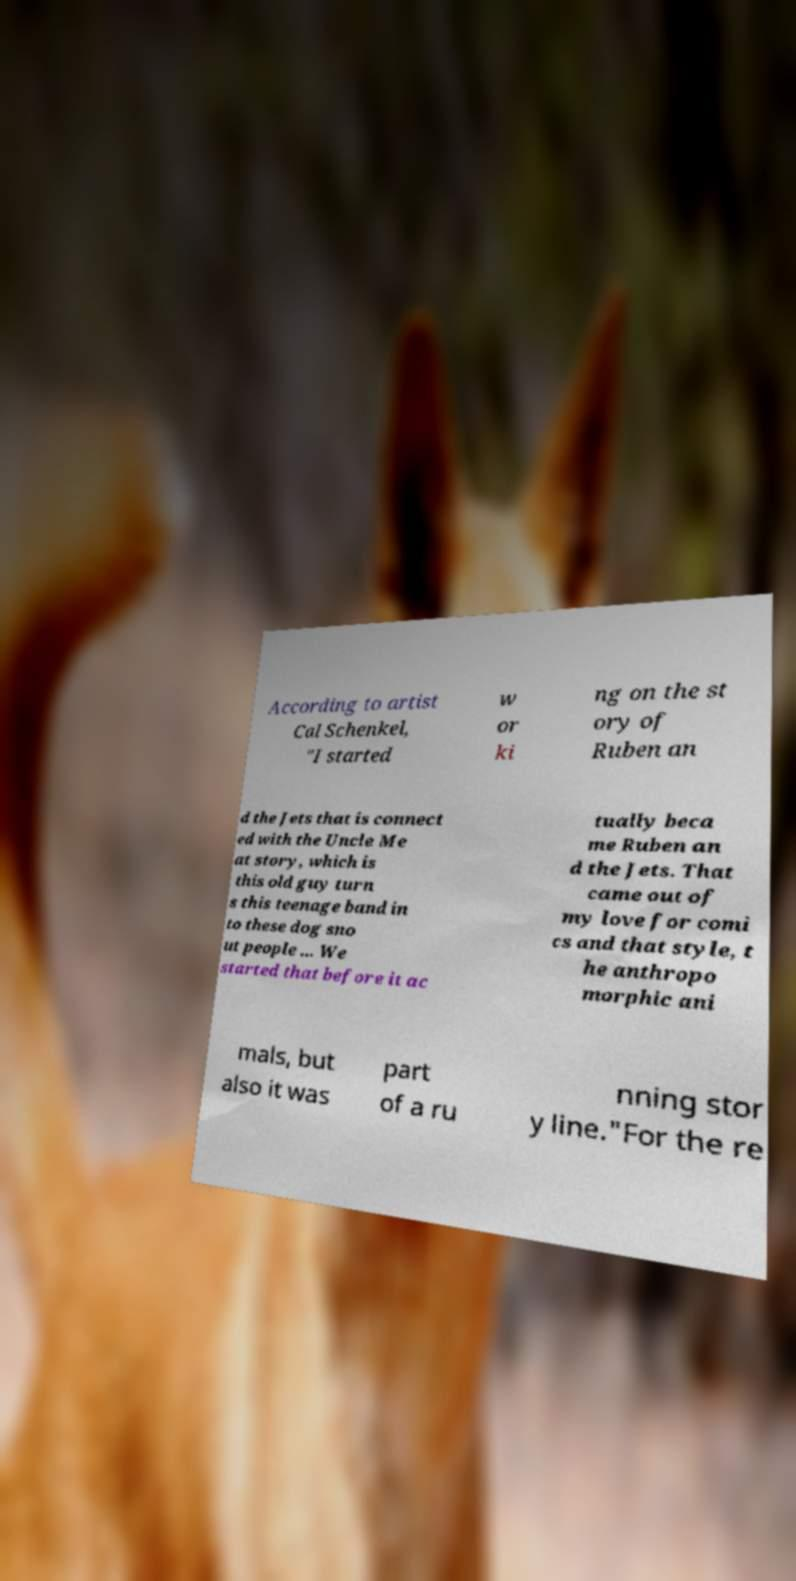I need the written content from this picture converted into text. Can you do that? According to artist Cal Schenkel, "I started w or ki ng on the st ory of Ruben an d the Jets that is connect ed with the Uncle Me at story, which is this old guy turn s this teenage band in to these dog sno ut people ... We started that before it ac tually beca me Ruben an d the Jets. That came out of my love for comi cs and that style, t he anthropo morphic ani mals, but also it was part of a ru nning stor y line."For the re 